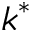Convert formula to latex. <formula><loc_0><loc_0><loc_500><loc_500>k ^ { * }</formula> 